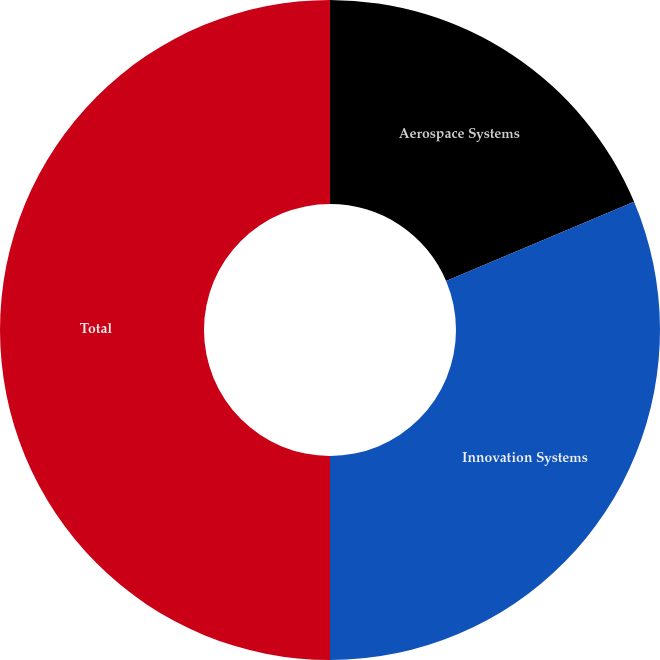<chart> <loc_0><loc_0><loc_500><loc_500><pie_chart><fcel>Aerospace Systems<fcel>Innovation Systems<fcel>Total<nl><fcel>18.65%<fcel>31.35%<fcel>50.0%<nl></chart> 